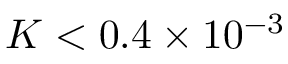<formula> <loc_0><loc_0><loc_500><loc_500>K < 0 . 4 \times 1 0 ^ { - 3 }</formula> 